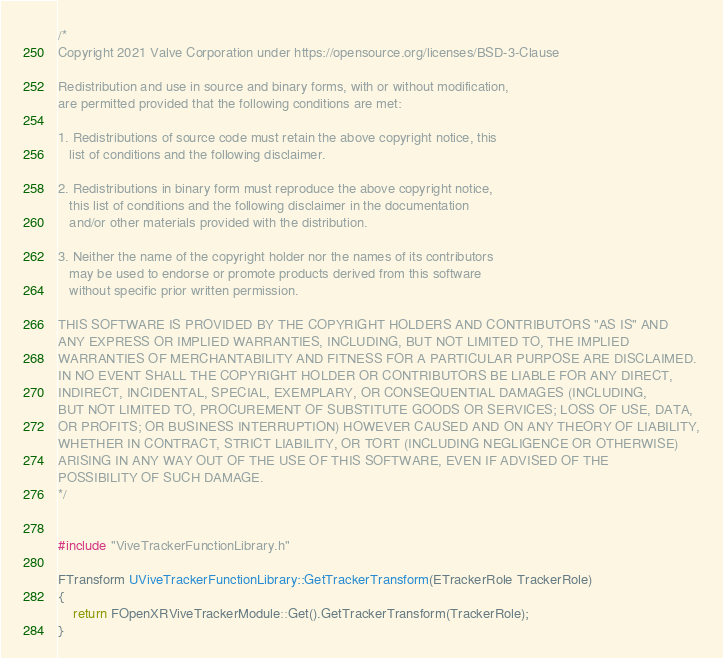<code> <loc_0><loc_0><loc_500><loc_500><_C++_>/*
Copyright 2021 Valve Corporation under https://opensource.org/licenses/BSD-3-Clause

Redistribution and use in source and binary forms, with or without modification,
are permitted provided that the following conditions are met:

1. Redistributions of source code must retain the above copyright notice, this
   list of conditions and the following disclaimer.

2. Redistributions in binary form must reproduce the above copyright notice,
   this list of conditions and the following disclaimer in the documentation
   and/or other materials provided with the distribution.

3. Neither the name of the copyright holder nor the names of its contributors
   may be used to endorse or promote products derived from this software
   without specific prior written permission.

THIS SOFTWARE IS PROVIDED BY THE COPYRIGHT HOLDERS AND CONTRIBUTORS "AS IS" AND
ANY EXPRESS OR IMPLIED WARRANTIES, INCLUDING, BUT NOT LIMITED TO, THE IMPLIED
WARRANTIES OF MERCHANTABILITY AND FITNESS FOR A PARTICULAR PURPOSE ARE DISCLAIMED.
IN NO EVENT SHALL THE COPYRIGHT HOLDER OR CONTRIBUTORS BE LIABLE FOR ANY DIRECT,
INDIRECT, INCIDENTAL, SPECIAL, EXEMPLARY, OR CONSEQUENTIAL DAMAGES (INCLUDING,
BUT NOT LIMITED TO, PROCUREMENT OF SUBSTITUTE GOODS OR SERVICES; LOSS OF USE, DATA,
OR PROFITS; OR BUSINESS INTERRUPTION) HOWEVER CAUSED AND ON ANY THEORY OF LIABILITY,
WHETHER IN CONTRACT, STRICT LIABILITY, OR TORT (INCLUDING NEGLIGENCE OR OTHERWISE)
ARISING IN ANY WAY OUT OF THE USE OF THIS SOFTWARE, EVEN IF ADVISED OF THE
POSSIBILITY OF SUCH DAMAGE.
*/


#include "ViveTrackerFunctionLibrary.h"

FTransform UViveTrackerFunctionLibrary::GetTrackerTransform(ETrackerRole TrackerRole)
{
	return FOpenXRViveTrackerModule::Get().GetTrackerTransform(TrackerRole);
}
</code> 